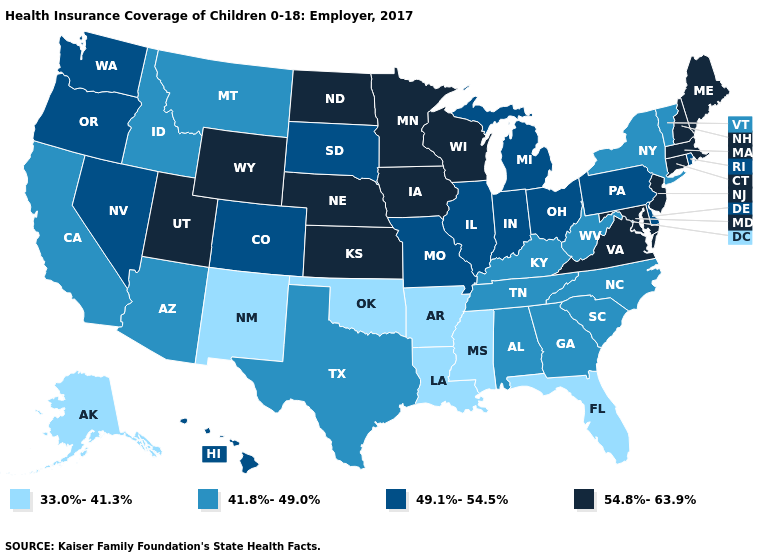Which states hav the highest value in the West?
Give a very brief answer. Utah, Wyoming. Among the states that border Rhode Island , which have the highest value?
Answer briefly. Connecticut, Massachusetts. What is the value of New Mexico?
Keep it brief. 33.0%-41.3%. Name the states that have a value in the range 49.1%-54.5%?
Write a very short answer. Colorado, Delaware, Hawaii, Illinois, Indiana, Michigan, Missouri, Nevada, Ohio, Oregon, Pennsylvania, Rhode Island, South Dakota, Washington. Name the states that have a value in the range 41.8%-49.0%?
Short answer required. Alabama, Arizona, California, Georgia, Idaho, Kentucky, Montana, New York, North Carolina, South Carolina, Tennessee, Texas, Vermont, West Virginia. Which states hav the highest value in the MidWest?
Be succinct. Iowa, Kansas, Minnesota, Nebraska, North Dakota, Wisconsin. Does Arkansas have a lower value than Mississippi?
Write a very short answer. No. Name the states that have a value in the range 49.1%-54.5%?
Concise answer only. Colorado, Delaware, Hawaii, Illinois, Indiana, Michigan, Missouri, Nevada, Ohio, Oregon, Pennsylvania, Rhode Island, South Dakota, Washington. What is the value of California?
Write a very short answer. 41.8%-49.0%. What is the highest value in the South ?
Answer briefly. 54.8%-63.9%. What is the value of Alabama?
Answer briefly. 41.8%-49.0%. Does Vermont have the highest value in the Northeast?
Write a very short answer. No. What is the value of Ohio?
Keep it brief. 49.1%-54.5%. Does Connecticut have the same value as New York?
Short answer required. No. Which states hav the highest value in the MidWest?
Answer briefly. Iowa, Kansas, Minnesota, Nebraska, North Dakota, Wisconsin. 